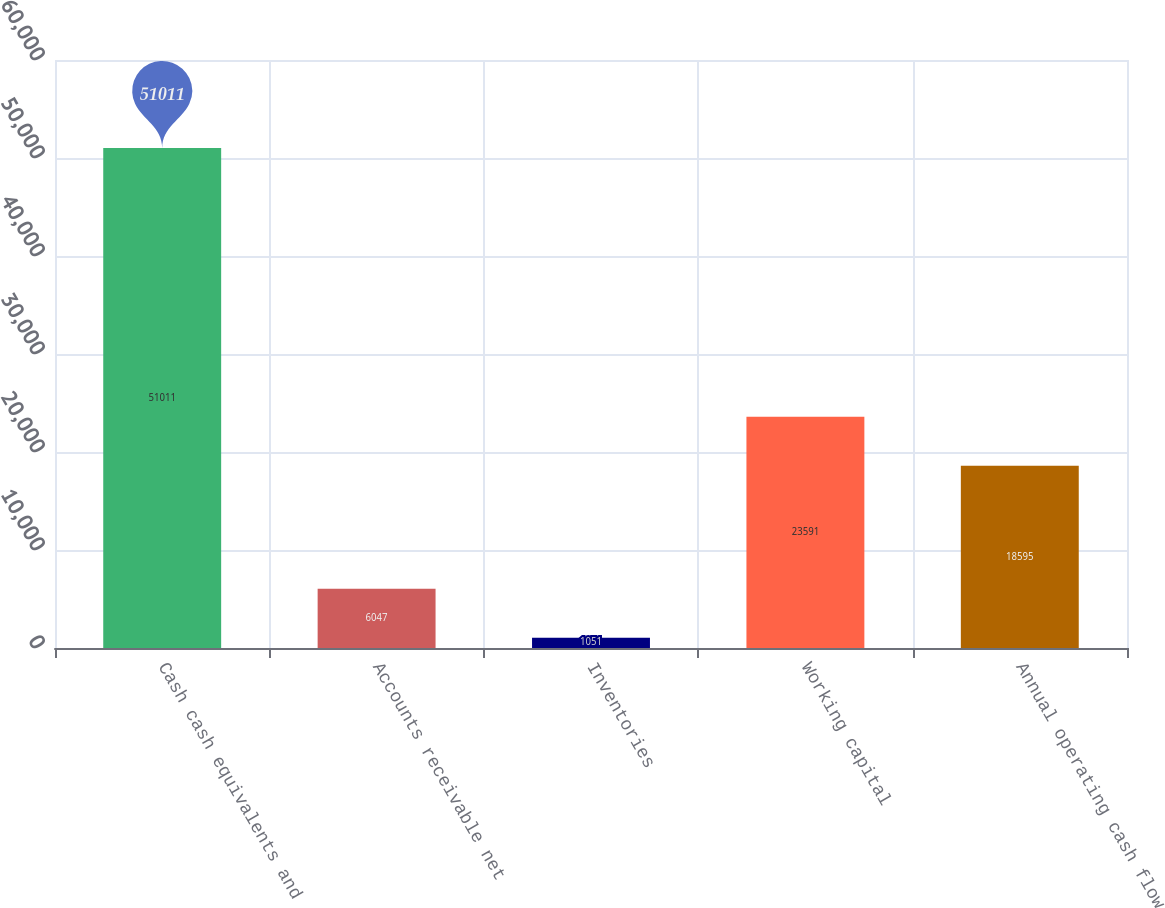<chart> <loc_0><loc_0><loc_500><loc_500><bar_chart><fcel>Cash cash equivalents and<fcel>Accounts receivable net<fcel>Inventories<fcel>Working capital<fcel>Annual operating cash flow<nl><fcel>51011<fcel>6047<fcel>1051<fcel>23591<fcel>18595<nl></chart> 